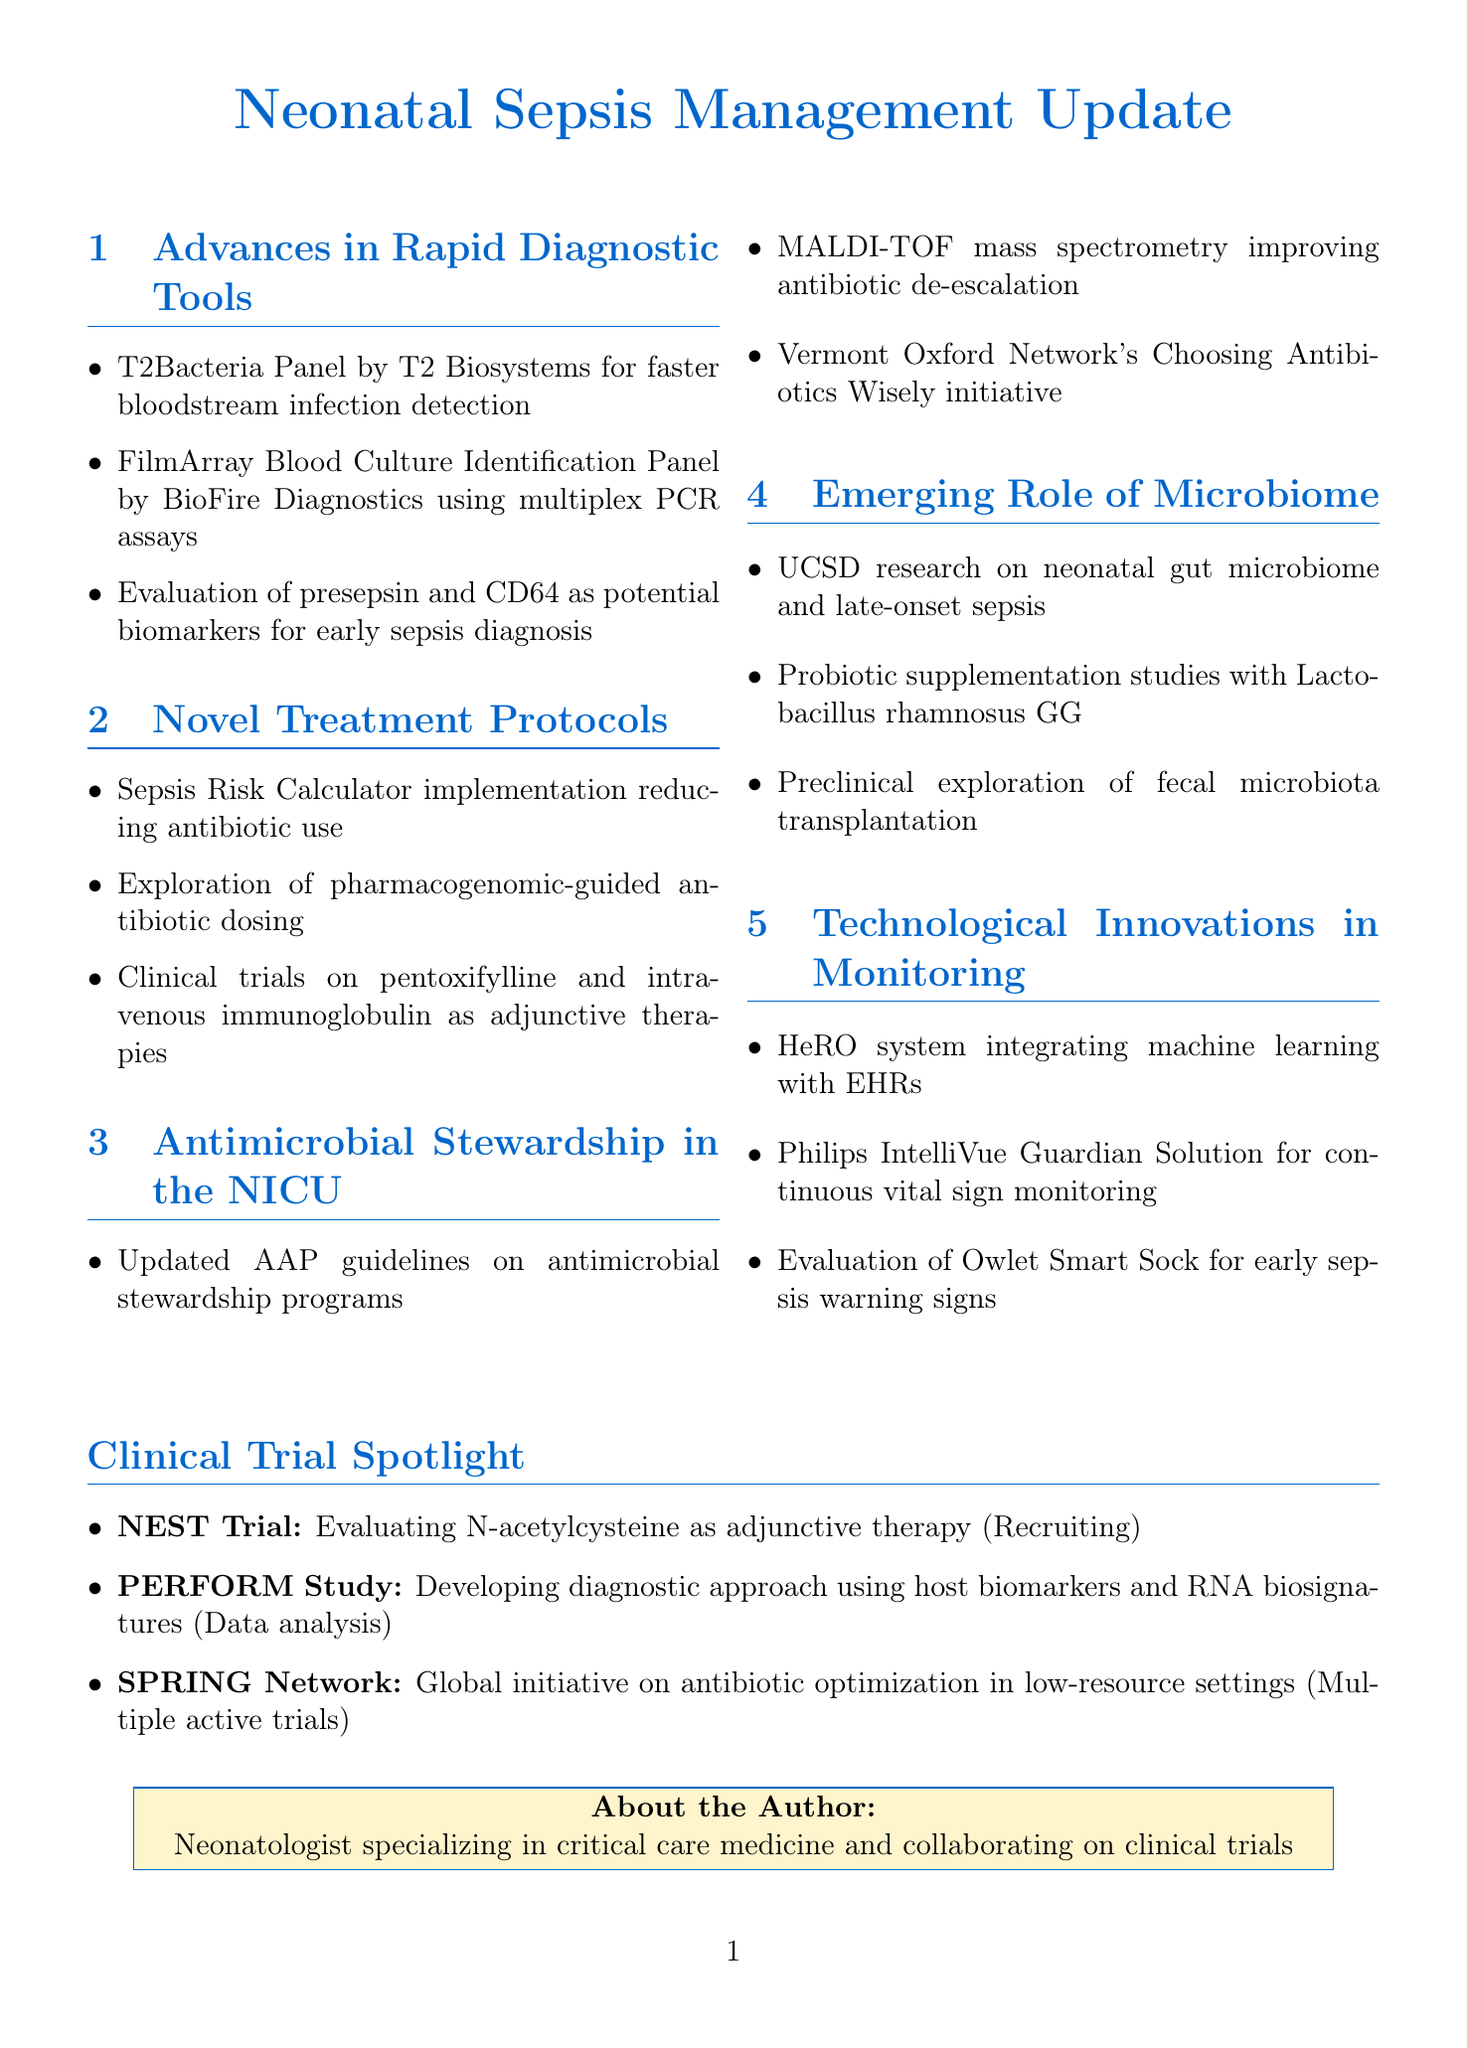What is the title of the newsletter? The title of the newsletter is found at the top of the document, which is "Neonatal Sepsis Management Update."
Answer: Neonatal Sepsis Management Update What diagnostic tool allows for faster detection of bloodstream infections? The document mentions the T2Bacteria Panel by T2 Biosystems as a tool for faster detection.
Answer: T2Bacteria Panel Which biomarker is being evaluated for early sepsis diagnosis? The document lists presepsin as a biomarker being evaluated for early sepsis diagnosis.
Answer: presepsin What is the NEST Trial focusing on? The NEST Trial is focused on evaluating N-acetylcysteine as an adjunctive therapy in neonatal sepsis.
Answer: N-acetylcysteine How has the Sepsis Risk Calculator impacted antibiotic use? The document states that the implementation of the Sepsis Risk Calculator has led to a significant reduction in antibiotic use.
Answer: Reduction in antibiotic use Which organization released updated guidelines on antimicrobial stewardship? The American Academy of Pediatrics released updated guidelines on antimicrobial stewardship programs.
Answer: American Academy of Pediatrics What is the current status of the PERFORM Study? The current status of the PERFORM Study is noted as being in the data analysis phase.
Answer: Data analysis phase What innovative system integrates machine learning with electronic health records? The HeRO system is mentioned as the innovative system that integrates machine learning with electronic health records.
Answer: HeRO system 